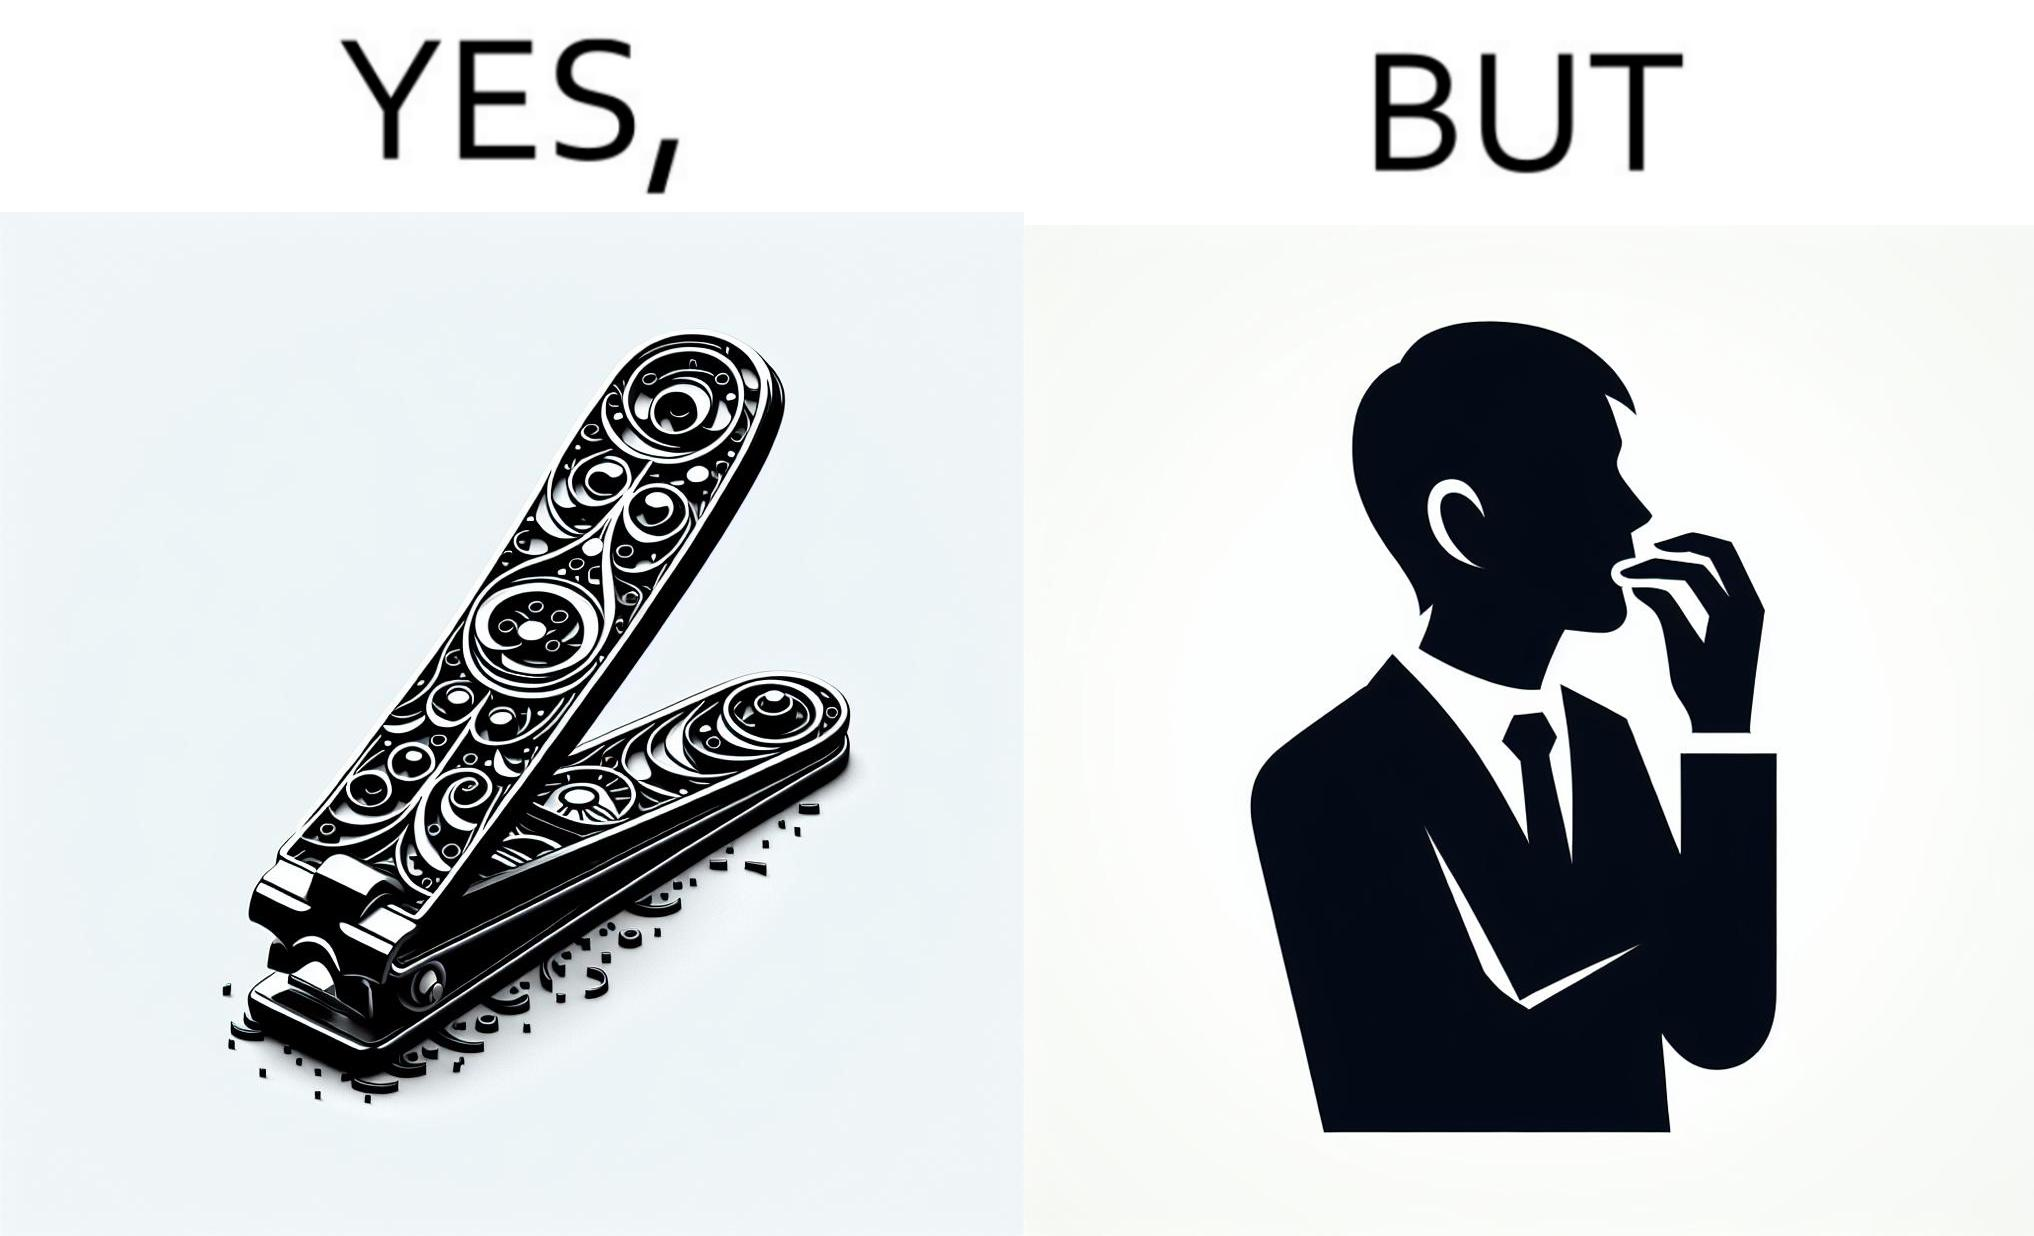Describe what you see in the left and right parts of this image. In the left part of the image: a nail clipper In the right part of the image: a person biting their nails to cut them 